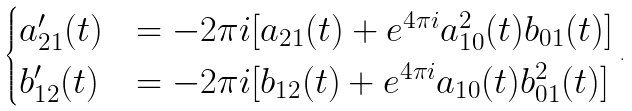Convert formula to latex. <formula><loc_0><loc_0><loc_500><loc_500>\begin{cases} a _ { 2 1 } ^ { \prime } ( t ) & = - 2 \pi i [ a _ { 2 1 } ( t ) + e ^ { 4 \pi i } a _ { 1 0 } ^ { 2 } ( t ) b _ { 0 1 } ( t ) ] \\ b _ { 1 2 } ^ { \prime } ( t ) & = - 2 \pi i [ b _ { 1 2 } ( t ) + e ^ { 4 \pi i } a _ { 1 0 } ( t ) b _ { 0 1 } ^ { 2 } ( t ) ] \end{cases} \, .</formula> 